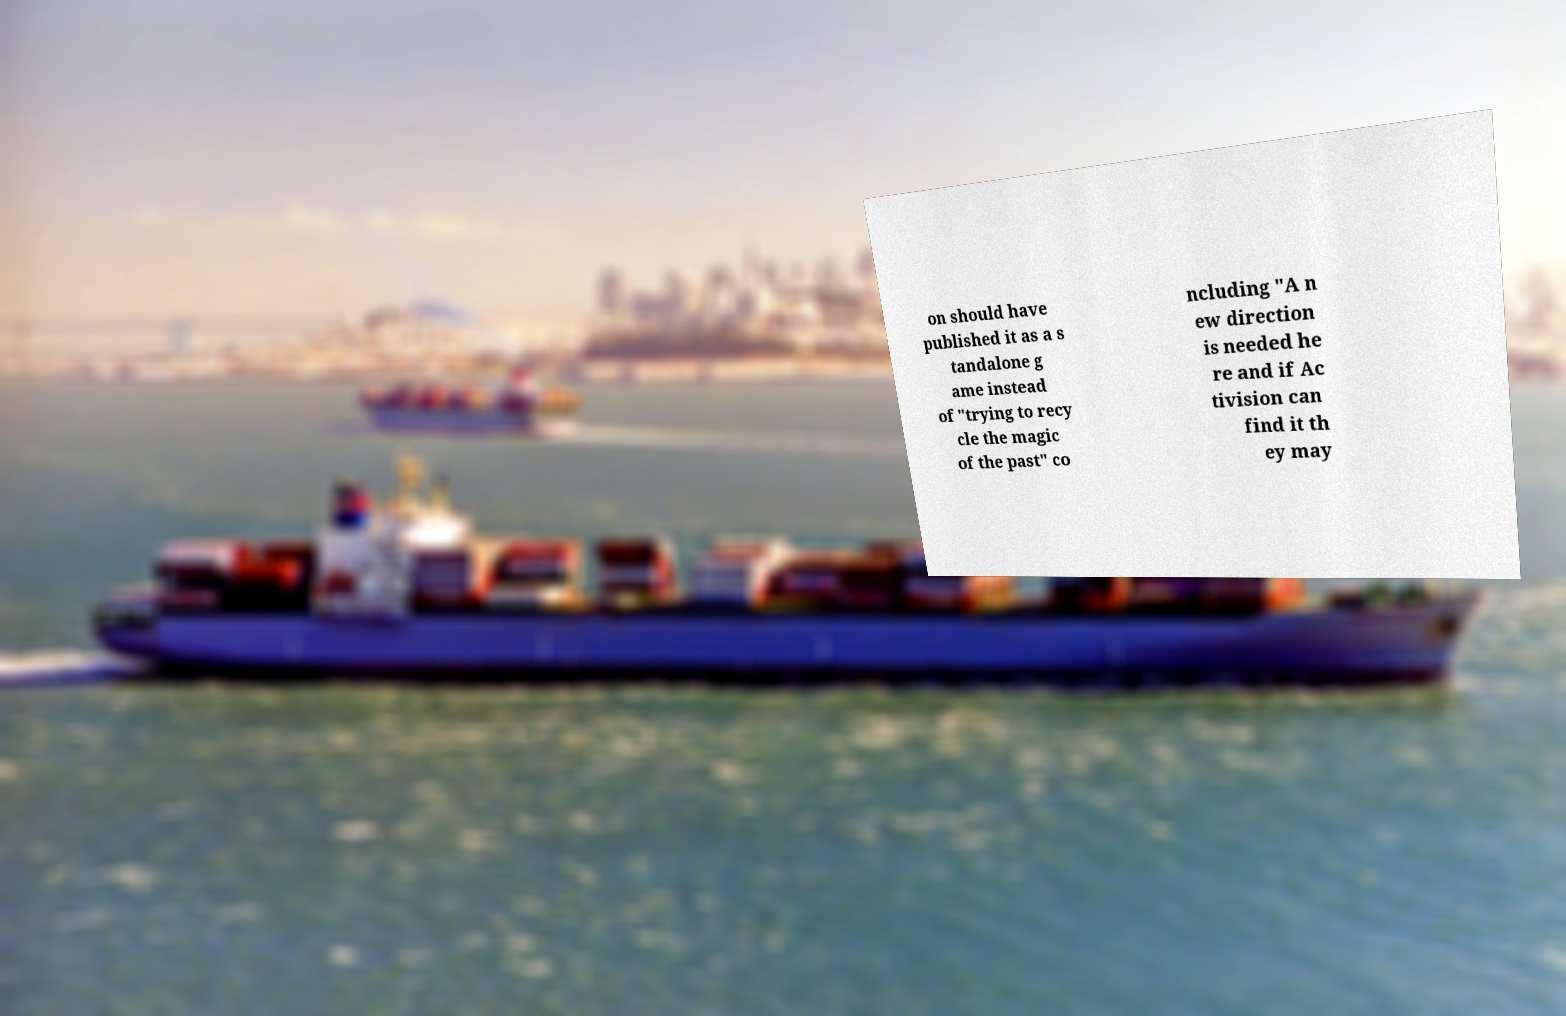There's text embedded in this image that I need extracted. Can you transcribe it verbatim? on should have published it as a s tandalone g ame instead of "trying to recy cle the magic of the past" co ncluding "A n ew direction is needed he re and if Ac tivision can find it th ey may 